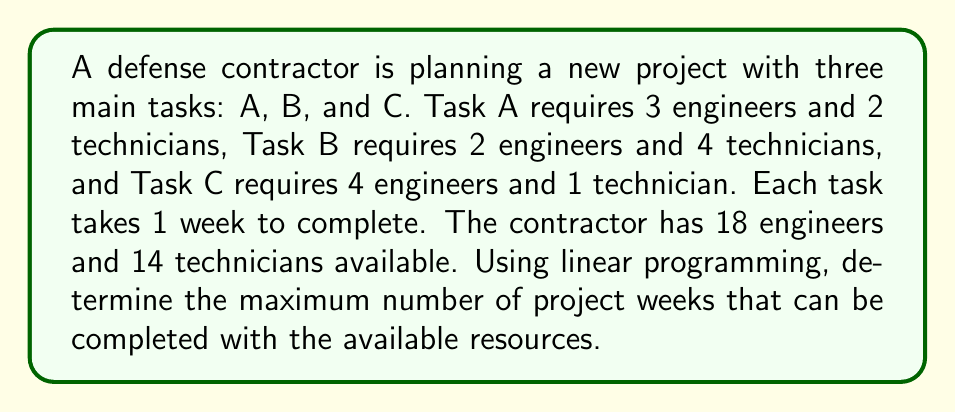Provide a solution to this math problem. Let's approach this step-by-step using linear programming:

1. Define variables:
   Let $x$, $y$, and $z$ be the number of weeks spent on Tasks A, B, and C respectively.

2. Set up the objective function:
   We want to maximize the total number of project weeks:
   $\text{Maximize } f(x,y,z) = x + y + z$

3. Establish constraints:
   a) Engineer constraint: $3x + 2y + 4z \leq 18$
   b) Technician constraint: $2x + 4y + z \leq 14$
   c) Non-negativity: $x \geq 0, y \geq 0, z \geq 0$

4. Solve using the simplex method or graphical method. In this case, we can use the graphical method as we effectively have two variables (treating $z$ as a parameter).

5. The feasible region is bounded by the lines:
   $3x + 2y = 18 - 4z$
   $2x + 4y = 14 - z$

6. The optimal solution will occur at the intersection of these lines:
   Solving simultaneously:
   $3x + 2y = 18 - 4z$
   $2x + 4y = 14 - z$

   Multiplying the first equation by 2 and the second by 3:
   $6x + 4y = 36 - 8z$
   $6x + 12y = 42 - 3z$

   Subtracting:
   $-8y = -6 + 5z$
   $y = \frac{3}{4} - \frac{5}{8}z$

   Substituting back into $2x + 4y = 14 - z$:
   $2x + 4(\frac{3}{4} - \frac{5}{8}z) = 14 - z$
   $2x + 3 - \frac{5}{2}z = 14 - z$
   $2x = 11 + \frac{3}{2}z$
   $x = \frac{11}{2} + \frac{3}{4}z$

7. The optimal solution is:
   $x = \frac{11}{2} + \frac{3}{4}z$
   $y = \frac{3}{4} - \frac{5}{8}z$
   $z = z$

8. To maximize $x + y + z$, we substitute these expressions:
   $f(z) = (\frac{11}{2} + \frac{3}{4}z) + (\frac{3}{4} - \frac{5}{8}z) + z$
         $= \frac{11}{2} + \frac{3}{4} + \frac{9}{8}z$
         $= \frac{13}{2} + \frac{9}{8}z$

9. Since this is an increasing function of $z$, we want the maximum possible $z$. This occurs when $y = 0$:
   $0 = \frac{3}{4} - \frac{5}{8}z$
   $z = \frac{6}{5} = 1.2$

10. Substituting back:
    $x = \frac{11}{2} + \frac{3}{4}(1.2) = 5.9$
    $y = 0$
    $z = 1.2$

11. The maximum number of project weeks is the sum of these values:
    $5.9 + 0 + 1.2 = 7.1$ weeks
Answer: 7.1 weeks 